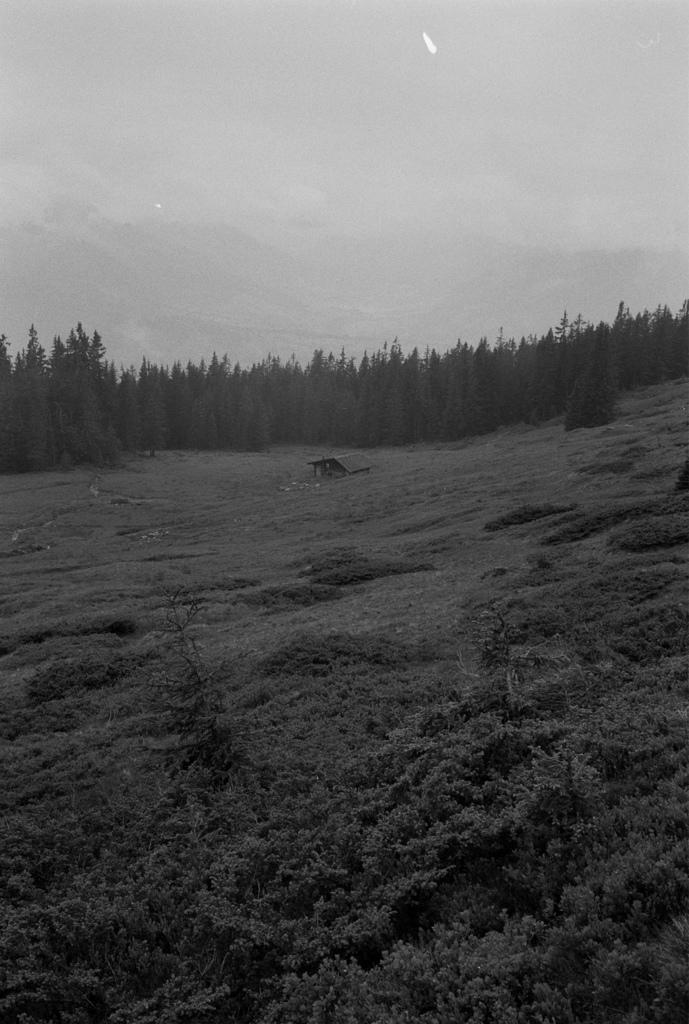What type of living organisms can be seen in the image? Plants can be seen in the image. What structure is located on the ground in the image? There is a shed on the ground in the image. What can be seen in the background of the image? There are trees and the sky visible in the background of the image. Can you see any thumbs growing on the plants in the image? There are no thumbs present on the plants in the image, as thumbs are a body part found on humans and not a part of plants. Are there any berries visible on the plants in the image? The provided facts do not mention any berries on the plants in the image, so we cannot definitively answer that question. 